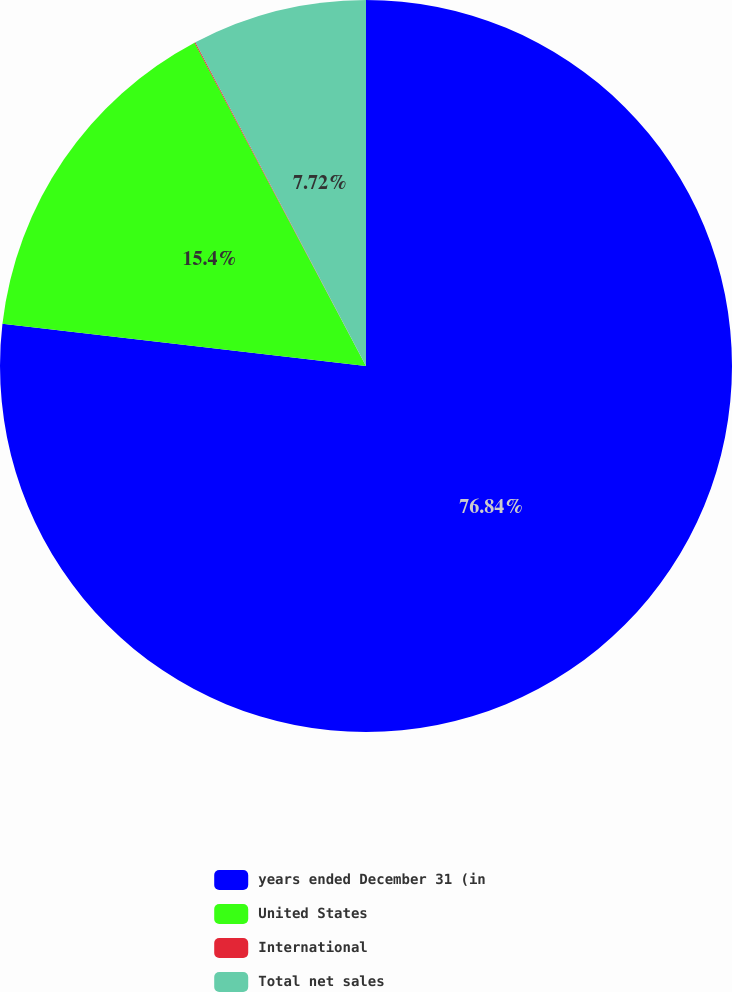Convert chart. <chart><loc_0><loc_0><loc_500><loc_500><pie_chart><fcel>years ended December 31 (in<fcel>United States<fcel>International<fcel>Total net sales<nl><fcel>76.84%<fcel>15.4%<fcel>0.04%<fcel>7.72%<nl></chart> 